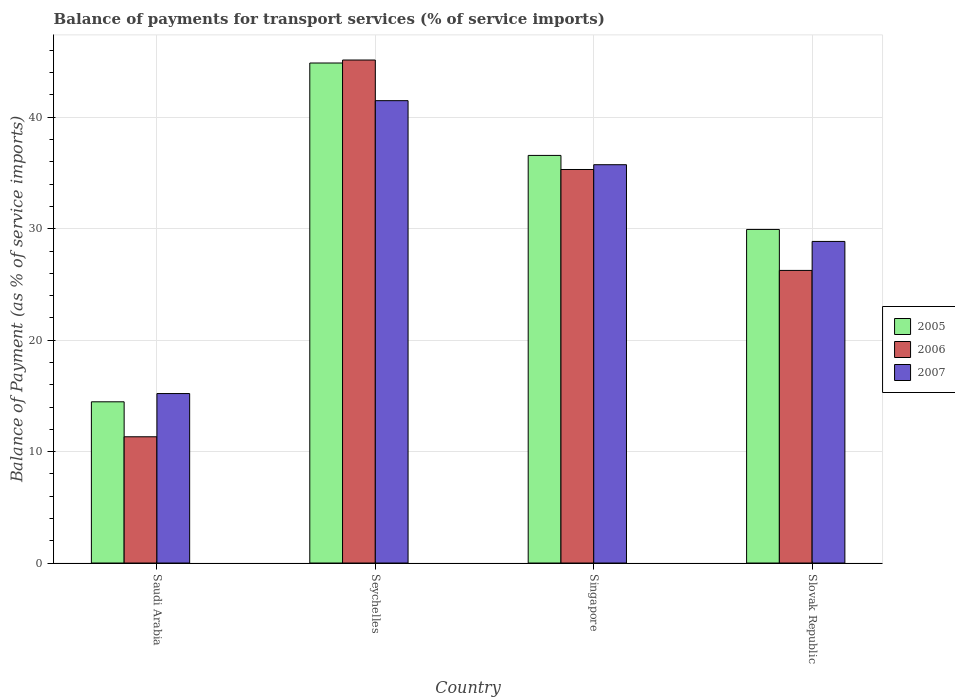Are the number of bars per tick equal to the number of legend labels?
Provide a succinct answer. Yes. How many bars are there on the 1st tick from the left?
Ensure brevity in your answer.  3. How many bars are there on the 2nd tick from the right?
Provide a short and direct response. 3. What is the label of the 1st group of bars from the left?
Offer a terse response. Saudi Arabia. What is the balance of payments for transport services in 2006 in Saudi Arabia?
Make the answer very short. 11.33. Across all countries, what is the maximum balance of payments for transport services in 2006?
Keep it short and to the point. 45.14. Across all countries, what is the minimum balance of payments for transport services in 2006?
Provide a succinct answer. 11.33. In which country was the balance of payments for transport services in 2006 maximum?
Provide a succinct answer. Seychelles. In which country was the balance of payments for transport services in 2005 minimum?
Provide a short and direct response. Saudi Arabia. What is the total balance of payments for transport services in 2005 in the graph?
Provide a short and direct response. 125.85. What is the difference between the balance of payments for transport services in 2007 in Seychelles and that in Singapore?
Provide a short and direct response. 5.75. What is the difference between the balance of payments for transport services in 2007 in Slovak Republic and the balance of payments for transport services in 2005 in Singapore?
Offer a very short reply. -7.72. What is the average balance of payments for transport services in 2007 per country?
Provide a succinct answer. 30.33. What is the difference between the balance of payments for transport services of/in 2005 and balance of payments for transport services of/in 2007 in Singapore?
Provide a short and direct response. 0.83. What is the ratio of the balance of payments for transport services in 2006 in Singapore to that in Slovak Republic?
Make the answer very short. 1.34. Is the difference between the balance of payments for transport services in 2005 in Saudi Arabia and Seychelles greater than the difference between the balance of payments for transport services in 2007 in Saudi Arabia and Seychelles?
Provide a short and direct response. No. What is the difference between the highest and the second highest balance of payments for transport services in 2007?
Make the answer very short. 5.75. What is the difference between the highest and the lowest balance of payments for transport services in 2005?
Your answer should be very brief. 30.4. In how many countries, is the balance of payments for transport services in 2006 greater than the average balance of payments for transport services in 2006 taken over all countries?
Your answer should be very brief. 2. What does the 2nd bar from the left in Singapore represents?
Your response must be concise. 2006. What does the 3rd bar from the right in Saudi Arabia represents?
Give a very brief answer. 2005. Are all the bars in the graph horizontal?
Provide a succinct answer. No. What is the difference between two consecutive major ticks on the Y-axis?
Make the answer very short. 10. Are the values on the major ticks of Y-axis written in scientific E-notation?
Offer a terse response. No. Does the graph contain any zero values?
Make the answer very short. No. Does the graph contain grids?
Give a very brief answer. Yes. Where does the legend appear in the graph?
Ensure brevity in your answer.  Center right. What is the title of the graph?
Your response must be concise. Balance of payments for transport services (% of service imports). Does "1976" appear as one of the legend labels in the graph?
Keep it short and to the point. No. What is the label or title of the Y-axis?
Keep it short and to the point. Balance of Payment (as % of service imports). What is the Balance of Payment (as % of service imports) in 2005 in Saudi Arabia?
Provide a succinct answer. 14.47. What is the Balance of Payment (as % of service imports) of 2006 in Saudi Arabia?
Ensure brevity in your answer.  11.33. What is the Balance of Payment (as % of service imports) of 2007 in Saudi Arabia?
Give a very brief answer. 15.21. What is the Balance of Payment (as % of service imports) in 2005 in Seychelles?
Keep it short and to the point. 44.87. What is the Balance of Payment (as % of service imports) in 2006 in Seychelles?
Give a very brief answer. 45.14. What is the Balance of Payment (as % of service imports) of 2007 in Seychelles?
Make the answer very short. 41.49. What is the Balance of Payment (as % of service imports) of 2005 in Singapore?
Your answer should be compact. 36.58. What is the Balance of Payment (as % of service imports) of 2006 in Singapore?
Provide a short and direct response. 35.31. What is the Balance of Payment (as % of service imports) in 2007 in Singapore?
Make the answer very short. 35.74. What is the Balance of Payment (as % of service imports) of 2005 in Slovak Republic?
Your response must be concise. 29.93. What is the Balance of Payment (as % of service imports) of 2006 in Slovak Republic?
Offer a terse response. 26.26. What is the Balance of Payment (as % of service imports) of 2007 in Slovak Republic?
Make the answer very short. 28.86. Across all countries, what is the maximum Balance of Payment (as % of service imports) of 2005?
Ensure brevity in your answer.  44.87. Across all countries, what is the maximum Balance of Payment (as % of service imports) in 2006?
Provide a short and direct response. 45.14. Across all countries, what is the maximum Balance of Payment (as % of service imports) in 2007?
Ensure brevity in your answer.  41.49. Across all countries, what is the minimum Balance of Payment (as % of service imports) in 2005?
Offer a very short reply. 14.47. Across all countries, what is the minimum Balance of Payment (as % of service imports) of 2006?
Make the answer very short. 11.33. Across all countries, what is the minimum Balance of Payment (as % of service imports) in 2007?
Your response must be concise. 15.21. What is the total Balance of Payment (as % of service imports) in 2005 in the graph?
Ensure brevity in your answer.  125.85. What is the total Balance of Payment (as % of service imports) in 2006 in the graph?
Keep it short and to the point. 118.04. What is the total Balance of Payment (as % of service imports) of 2007 in the graph?
Offer a terse response. 121.3. What is the difference between the Balance of Payment (as % of service imports) of 2005 in Saudi Arabia and that in Seychelles?
Ensure brevity in your answer.  -30.4. What is the difference between the Balance of Payment (as % of service imports) in 2006 in Saudi Arabia and that in Seychelles?
Ensure brevity in your answer.  -33.81. What is the difference between the Balance of Payment (as % of service imports) of 2007 in Saudi Arabia and that in Seychelles?
Give a very brief answer. -26.28. What is the difference between the Balance of Payment (as % of service imports) in 2005 in Saudi Arabia and that in Singapore?
Your answer should be very brief. -22.11. What is the difference between the Balance of Payment (as % of service imports) in 2006 in Saudi Arabia and that in Singapore?
Ensure brevity in your answer.  -23.98. What is the difference between the Balance of Payment (as % of service imports) of 2007 in Saudi Arabia and that in Singapore?
Offer a very short reply. -20.54. What is the difference between the Balance of Payment (as % of service imports) in 2005 in Saudi Arabia and that in Slovak Republic?
Provide a short and direct response. -15.47. What is the difference between the Balance of Payment (as % of service imports) of 2006 in Saudi Arabia and that in Slovak Republic?
Offer a terse response. -14.93. What is the difference between the Balance of Payment (as % of service imports) in 2007 in Saudi Arabia and that in Slovak Republic?
Provide a short and direct response. -13.65. What is the difference between the Balance of Payment (as % of service imports) in 2005 in Seychelles and that in Singapore?
Offer a terse response. 8.29. What is the difference between the Balance of Payment (as % of service imports) in 2006 in Seychelles and that in Singapore?
Provide a succinct answer. 9.82. What is the difference between the Balance of Payment (as % of service imports) of 2007 in Seychelles and that in Singapore?
Your answer should be very brief. 5.75. What is the difference between the Balance of Payment (as % of service imports) in 2005 in Seychelles and that in Slovak Republic?
Your response must be concise. 14.94. What is the difference between the Balance of Payment (as % of service imports) in 2006 in Seychelles and that in Slovak Republic?
Your answer should be very brief. 18.88. What is the difference between the Balance of Payment (as % of service imports) in 2007 in Seychelles and that in Slovak Republic?
Provide a succinct answer. 12.63. What is the difference between the Balance of Payment (as % of service imports) of 2005 in Singapore and that in Slovak Republic?
Your answer should be compact. 6.64. What is the difference between the Balance of Payment (as % of service imports) of 2006 in Singapore and that in Slovak Republic?
Make the answer very short. 9.06. What is the difference between the Balance of Payment (as % of service imports) of 2007 in Singapore and that in Slovak Republic?
Give a very brief answer. 6.88. What is the difference between the Balance of Payment (as % of service imports) in 2005 in Saudi Arabia and the Balance of Payment (as % of service imports) in 2006 in Seychelles?
Your answer should be compact. -30.67. What is the difference between the Balance of Payment (as % of service imports) of 2005 in Saudi Arabia and the Balance of Payment (as % of service imports) of 2007 in Seychelles?
Offer a very short reply. -27.02. What is the difference between the Balance of Payment (as % of service imports) in 2006 in Saudi Arabia and the Balance of Payment (as % of service imports) in 2007 in Seychelles?
Offer a terse response. -30.16. What is the difference between the Balance of Payment (as % of service imports) of 2005 in Saudi Arabia and the Balance of Payment (as % of service imports) of 2006 in Singapore?
Make the answer very short. -20.85. What is the difference between the Balance of Payment (as % of service imports) of 2005 in Saudi Arabia and the Balance of Payment (as % of service imports) of 2007 in Singapore?
Keep it short and to the point. -21.28. What is the difference between the Balance of Payment (as % of service imports) of 2006 in Saudi Arabia and the Balance of Payment (as % of service imports) of 2007 in Singapore?
Offer a very short reply. -24.41. What is the difference between the Balance of Payment (as % of service imports) of 2005 in Saudi Arabia and the Balance of Payment (as % of service imports) of 2006 in Slovak Republic?
Ensure brevity in your answer.  -11.79. What is the difference between the Balance of Payment (as % of service imports) of 2005 in Saudi Arabia and the Balance of Payment (as % of service imports) of 2007 in Slovak Republic?
Provide a succinct answer. -14.39. What is the difference between the Balance of Payment (as % of service imports) of 2006 in Saudi Arabia and the Balance of Payment (as % of service imports) of 2007 in Slovak Republic?
Your response must be concise. -17.53. What is the difference between the Balance of Payment (as % of service imports) in 2005 in Seychelles and the Balance of Payment (as % of service imports) in 2006 in Singapore?
Your answer should be very brief. 9.56. What is the difference between the Balance of Payment (as % of service imports) of 2005 in Seychelles and the Balance of Payment (as % of service imports) of 2007 in Singapore?
Give a very brief answer. 9.13. What is the difference between the Balance of Payment (as % of service imports) in 2006 in Seychelles and the Balance of Payment (as % of service imports) in 2007 in Singapore?
Ensure brevity in your answer.  9.39. What is the difference between the Balance of Payment (as % of service imports) of 2005 in Seychelles and the Balance of Payment (as % of service imports) of 2006 in Slovak Republic?
Provide a succinct answer. 18.61. What is the difference between the Balance of Payment (as % of service imports) in 2005 in Seychelles and the Balance of Payment (as % of service imports) in 2007 in Slovak Republic?
Offer a very short reply. 16.01. What is the difference between the Balance of Payment (as % of service imports) in 2006 in Seychelles and the Balance of Payment (as % of service imports) in 2007 in Slovak Republic?
Give a very brief answer. 16.28. What is the difference between the Balance of Payment (as % of service imports) of 2005 in Singapore and the Balance of Payment (as % of service imports) of 2006 in Slovak Republic?
Make the answer very short. 10.32. What is the difference between the Balance of Payment (as % of service imports) in 2005 in Singapore and the Balance of Payment (as % of service imports) in 2007 in Slovak Republic?
Ensure brevity in your answer.  7.72. What is the difference between the Balance of Payment (as % of service imports) in 2006 in Singapore and the Balance of Payment (as % of service imports) in 2007 in Slovak Republic?
Ensure brevity in your answer.  6.46. What is the average Balance of Payment (as % of service imports) of 2005 per country?
Your response must be concise. 31.46. What is the average Balance of Payment (as % of service imports) in 2006 per country?
Provide a short and direct response. 29.51. What is the average Balance of Payment (as % of service imports) of 2007 per country?
Your response must be concise. 30.33. What is the difference between the Balance of Payment (as % of service imports) in 2005 and Balance of Payment (as % of service imports) in 2006 in Saudi Arabia?
Your answer should be very brief. 3.14. What is the difference between the Balance of Payment (as % of service imports) in 2005 and Balance of Payment (as % of service imports) in 2007 in Saudi Arabia?
Your answer should be very brief. -0.74. What is the difference between the Balance of Payment (as % of service imports) of 2006 and Balance of Payment (as % of service imports) of 2007 in Saudi Arabia?
Your response must be concise. -3.88. What is the difference between the Balance of Payment (as % of service imports) of 2005 and Balance of Payment (as % of service imports) of 2006 in Seychelles?
Your answer should be compact. -0.27. What is the difference between the Balance of Payment (as % of service imports) of 2005 and Balance of Payment (as % of service imports) of 2007 in Seychelles?
Your answer should be very brief. 3.38. What is the difference between the Balance of Payment (as % of service imports) of 2006 and Balance of Payment (as % of service imports) of 2007 in Seychelles?
Offer a terse response. 3.65. What is the difference between the Balance of Payment (as % of service imports) in 2005 and Balance of Payment (as % of service imports) in 2006 in Singapore?
Your answer should be very brief. 1.26. What is the difference between the Balance of Payment (as % of service imports) of 2005 and Balance of Payment (as % of service imports) of 2007 in Singapore?
Your response must be concise. 0.83. What is the difference between the Balance of Payment (as % of service imports) in 2006 and Balance of Payment (as % of service imports) in 2007 in Singapore?
Give a very brief answer. -0.43. What is the difference between the Balance of Payment (as % of service imports) of 2005 and Balance of Payment (as % of service imports) of 2006 in Slovak Republic?
Offer a very short reply. 3.68. What is the difference between the Balance of Payment (as % of service imports) of 2005 and Balance of Payment (as % of service imports) of 2007 in Slovak Republic?
Your answer should be compact. 1.08. What is the difference between the Balance of Payment (as % of service imports) in 2006 and Balance of Payment (as % of service imports) in 2007 in Slovak Republic?
Your response must be concise. -2.6. What is the ratio of the Balance of Payment (as % of service imports) of 2005 in Saudi Arabia to that in Seychelles?
Offer a very short reply. 0.32. What is the ratio of the Balance of Payment (as % of service imports) in 2006 in Saudi Arabia to that in Seychelles?
Ensure brevity in your answer.  0.25. What is the ratio of the Balance of Payment (as % of service imports) in 2007 in Saudi Arabia to that in Seychelles?
Your answer should be compact. 0.37. What is the ratio of the Balance of Payment (as % of service imports) in 2005 in Saudi Arabia to that in Singapore?
Keep it short and to the point. 0.4. What is the ratio of the Balance of Payment (as % of service imports) of 2006 in Saudi Arabia to that in Singapore?
Your response must be concise. 0.32. What is the ratio of the Balance of Payment (as % of service imports) in 2007 in Saudi Arabia to that in Singapore?
Provide a short and direct response. 0.43. What is the ratio of the Balance of Payment (as % of service imports) of 2005 in Saudi Arabia to that in Slovak Republic?
Your response must be concise. 0.48. What is the ratio of the Balance of Payment (as % of service imports) of 2006 in Saudi Arabia to that in Slovak Republic?
Offer a terse response. 0.43. What is the ratio of the Balance of Payment (as % of service imports) of 2007 in Saudi Arabia to that in Slovak Republic?
Your answer should be compact. 0.53. What is the ratio of the Balance of Payment (as % of service imports) of 2005 in Seychelles to that in Singapore?
Provide a short and direct response. 1.23. What is the ratio of the Balance of Payment (as % of service imports) of 2006 in Seychelles to that in Singapore?
Your answer should be very brief. 1.28. What is the ratio of the Balance of Payment (as % of service imports) of 2007 in Seychelles to that in Singapore?
Your answer should be compact. 1.16. What is the ratio of the Balance of Payment (as % of service imports) of 2005 in Seychelles to that in Slovak Republic?
Offer a terse response. 1.5. What is the ratio of the Balance of Payment (as % of service imports) in 2006 in Seychelles to that in Slovak Republic?
Provide a succinct answer. 1.72. What is the ratio of the Balance of Payment (as % of service imports) of 2007 in Seychelles to that in Slovak Republic?
Your answer should be very brief. 1.44. What is the ratio of the Balance of Payment (as % of service imports) in 2005 in Singapore to that in Slovak Republic?
Offer a very short reply. 1.22. What is the ratio of the Balance of Payment (as % of service imports) of 2006 in Singapore to that in Slovak Republic?
Keep it short and to the point. 1.34. What is the ratio of the Balance of Payment (as % of service imports) of 2007 in Singapore to that in Slovak Republic?
Keep it short and to the point. 1.24. What is the difference between the highest and the second highest Balance of Payment (as % of service imports) of 2005?
Give a very brief answer. 8.29. What is the difference between the highest and the second highest Balance of Payment (as % of service imports) in 2006?
Make the answer very short. 9.82. What is the difference between the highest and the second highest Balance of Payment (as % of service imports) of 2007?
Offer a terse response. 5.75. What is the difference between the highest and the lowest Balance of Payment (as % of service imports) in 2005?
Offer a terse response. 30.4. What is the difference between the highest and the lowest Balance of Payment (as % of service imports) of 2006?
Provide a short and direct response. 33.81. What is the difference between the highest and the lowest Balance of Payment (as % of service imports) of 2007?
Offer a very short reply. 26.28. 